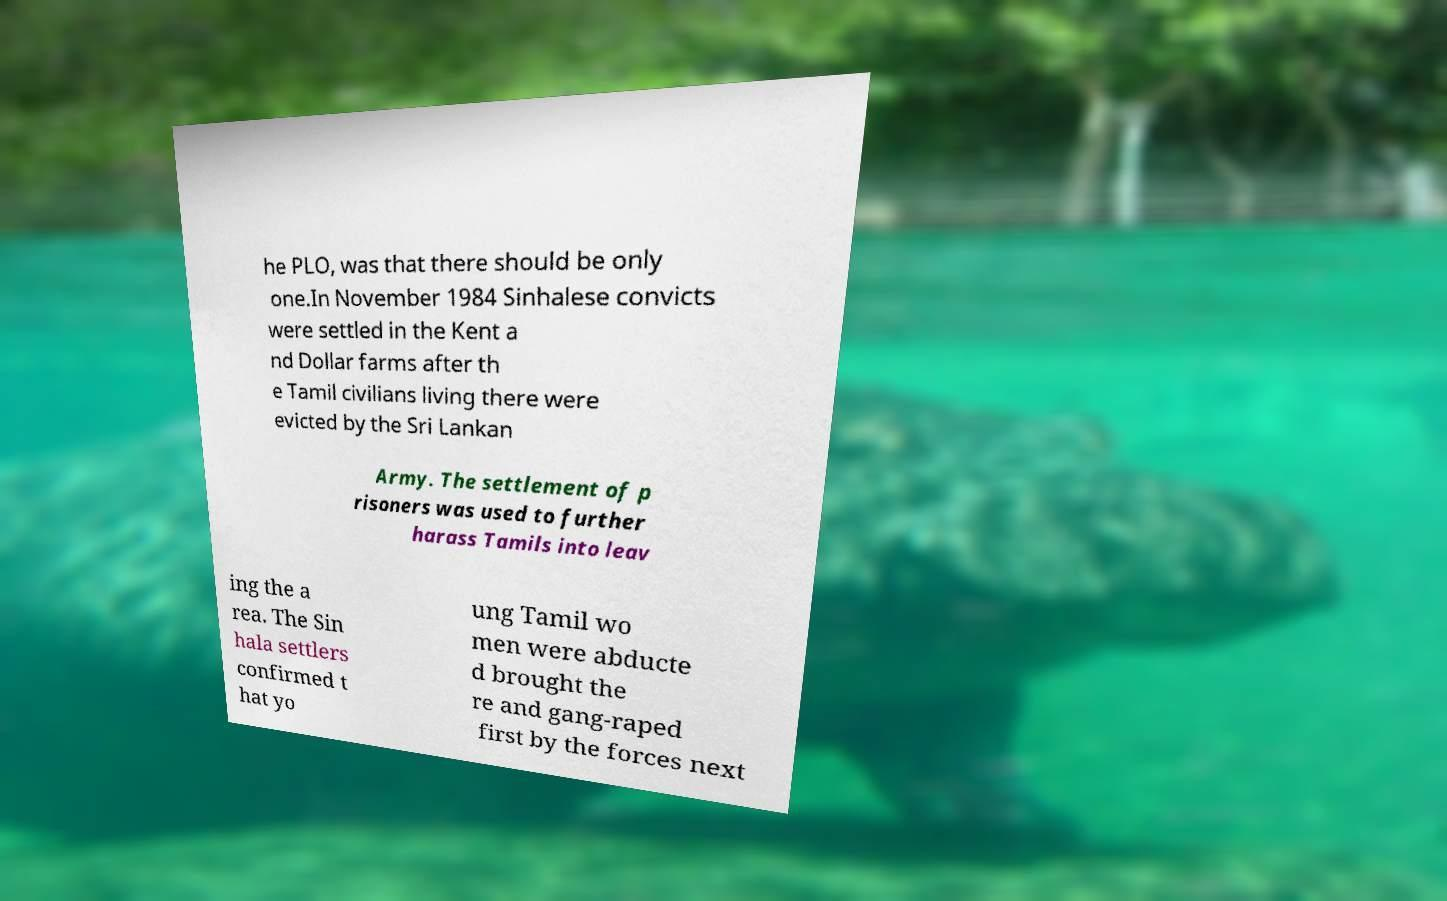Could you extract and type out the text from this image? he PLO, was that there should be only one.In November 1984 Sinhalese convicts were settled in the Kent a nd Dollar farms after th e Tamil civilians living there were evicted by the Sri Lankan Army. The settlement of p risoners was used to further harass Tamils into leav ing the a rea. The Sin hala settlers confirmed t hat yo ung Tamil wo men were abducte d brought the re and gang-raped first by the forces next 